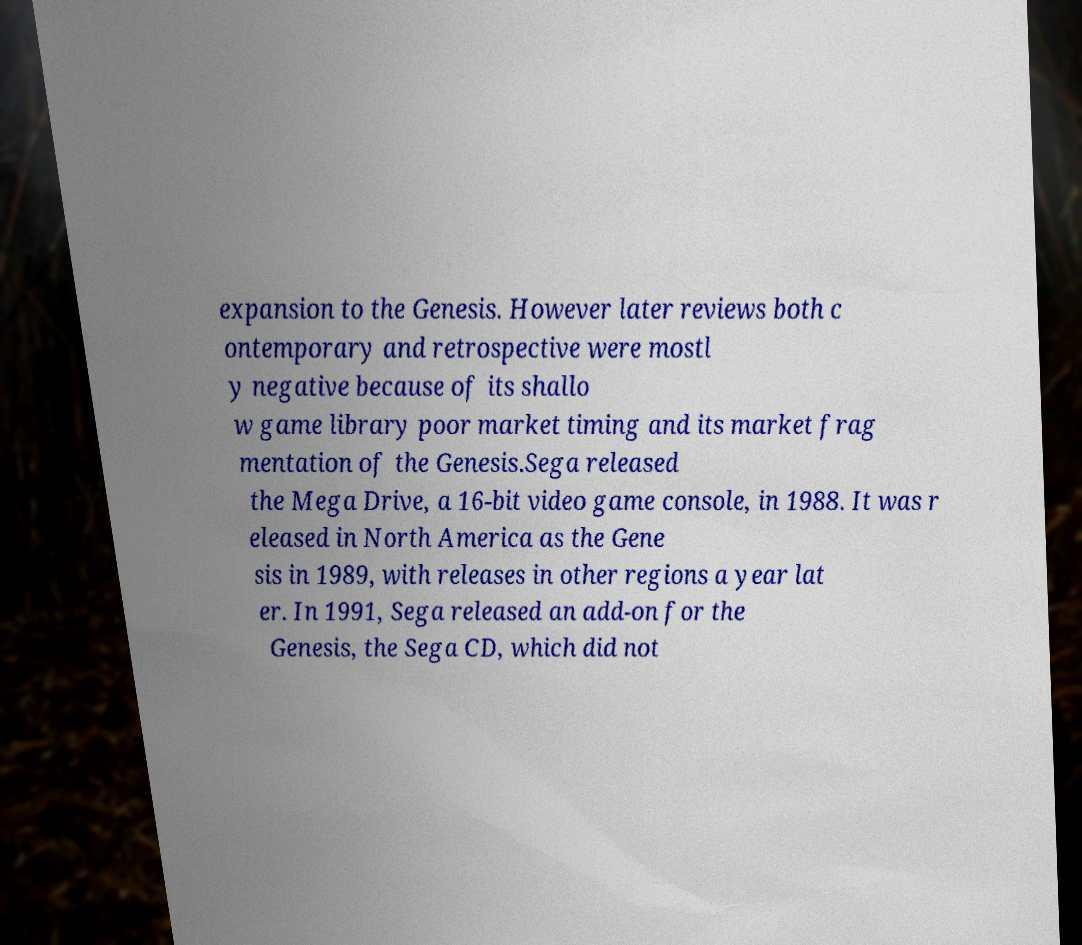There's text embedded in this image that I need extracted. Can you transcribe it verbatim? expansion to the Genesis. However later reviews both c ontemporary and retrospective were mostl y negative because of its shallo w game library poor market timing and its market frag mentation of the Genesis.Sega released the Mega Drive, a 16-bit video game console, in 1988. It was r eleased in North America as the Gene sis in 1989, with releases in other regions a year lat er. In 1991, Sega released an add-on for the Genesis, the Sega CD, which did not 